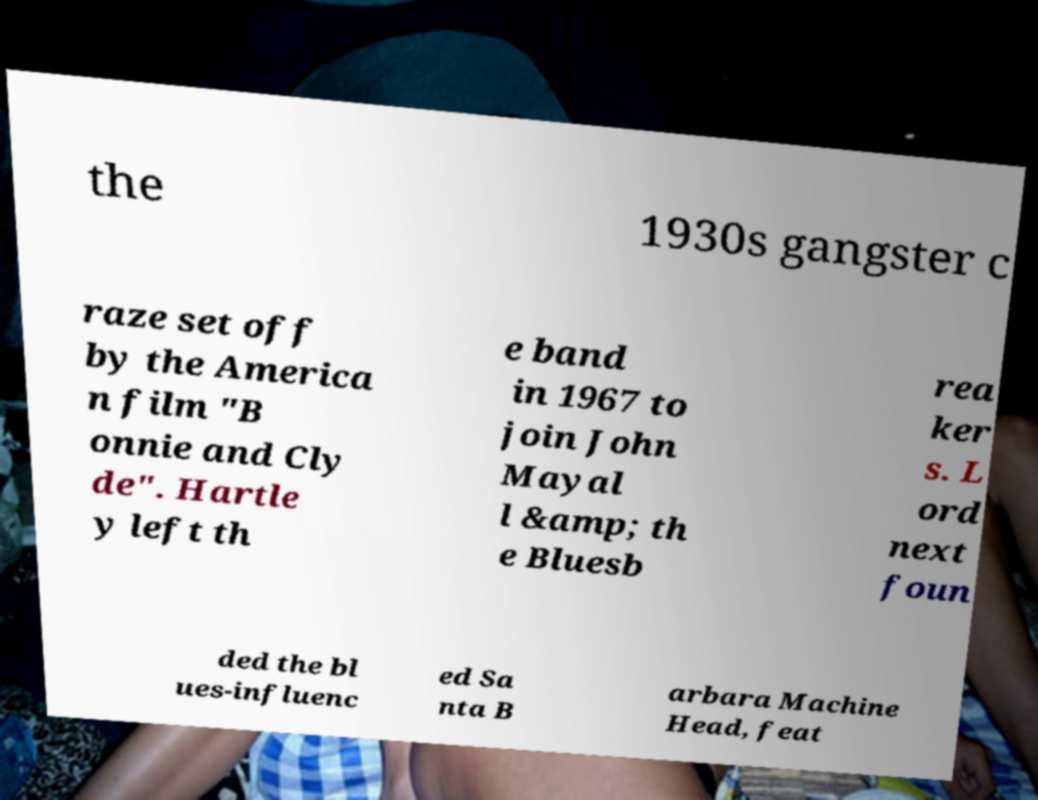Could you extract and type out the text from this image? the 1930s gangster c raze set off by the America n film "B onnie and Cly de". Hartle y left th e band in 1967 to join John Mayal l &amp; th e Bluesb rea ker s. L ord next foun ded the bl ues-influenc ed Sa nta B arbara Machine Head, feat 